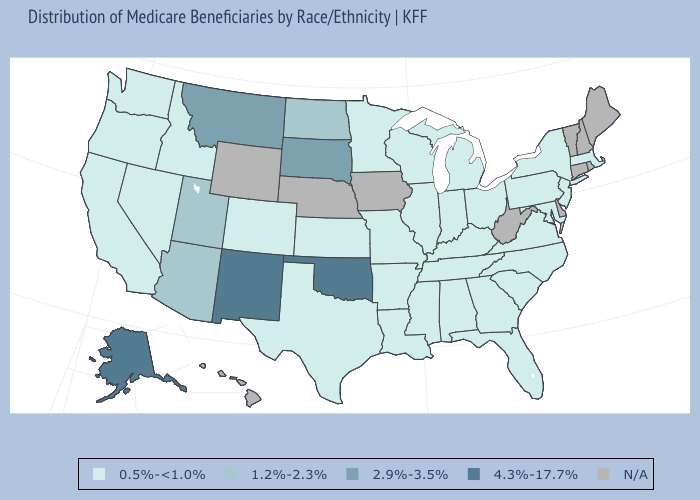Does New Mexico have the highest value in the West?
Be succinct. Yes. What is the value of Idaho?
Keep it brief. 0.5%-<1.0%. Name the states that have a value in the range 4.3%-17.7%?
Write a very short answer. Alaska, New Mexico, Oklahoma. What is the lowest value in the MidWest?
Short answer required. 0.5%-<1.0%. Name the states that have a value in the range 4.3%-17.7%?
Keep it brief. Alaska, New Mexico, Oklahoma. Does the first symbol in the legend represent the smallest category?
Quick response, please. Yes. Among the states that border South Dakota , which have the lowest value?
Short answer required. Minnesota. Does the map have missing data?
Be succinct. Yes. What is the value of Ohio?
Give a very brief answer. 0.5%-<1.0%. Which states have the highest value in the USA?
Concise answer only. Alaska, New Mexico, Oklahoma. Name the states that have a value in the range 0.5%-<1.0%?
Be succinct. Alabama, Arkansas, California, Colorado, Florida, Georgia, Idaho, Illinois, Indiana, Kansas, Kentucky, Louisiana, Maryland, Massachusetts, Michigan, Minnesota, Mississippi, Missouri, Nevada, New Jersey, New York, North Carolina, Ohio, Oregon, Pennsylvania, South Carolina, Tennessee, Texas, Virginia, Washington, Wisconsin. What is the value of Ohio?
Give a very brief answer. 0.5%-<1.0%. Which states hav the highest value in the West?
Short answer required. Alaska, New Mexico. Does New Mexico have the lowest value in the USA?
Short answer required. No. Name the states that have a value in the range 0.5%-<1.0%?
Short answer required. Alabama, Arkansas, California, Colorado, Florida, Georgia, Idaho, Illinois, Indiana, Kansas, Kentucky, Louisiana, Maryland, Massachusetts, Michigan, Minnesota, Mississippi, Missouri, Nevada, New Jersey, New York, North Carolina, Ohio, Oregon, Pennsylvania, South Carolina, Tennessee, Texas, Virginia, Washington, Wisconsin. 